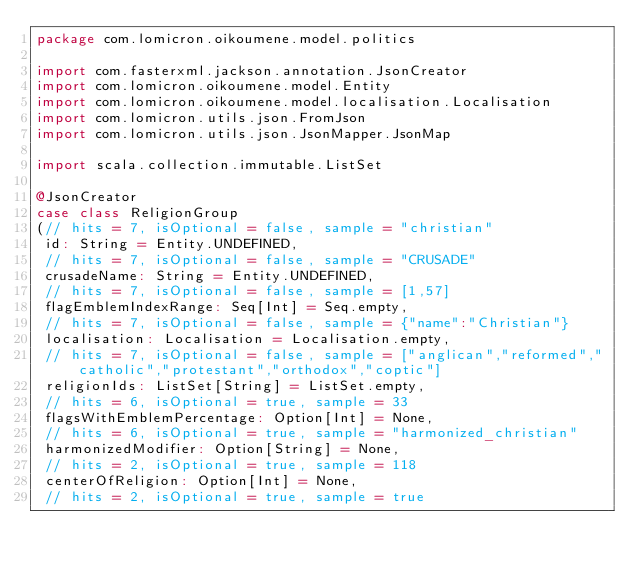Convert code to text. <code><loc_0><loc_0><loc_500><loc_500><_Scala_>package com.lomicron.oikoumene.model.politics

import com.fasterxml.jackson.annotation.JsonCreator
import com.lomicron.oikoumene.model.Entity
import com.lomicron.oikoumene.model.localisation.Localisation
import com.lomicron.utils.json.FromJson
import com.lomicron.utils.json.JsonMapper.JsonMap

import scala.collection.immutable.ListSet

@JsonCreator
case class ReligionGroup
(// hits = 7, isOptional = false, sample = "christian"
 id: String = Entity.UNDEFINED,
 // hits = 7, isOptional = false, sample = "CRUSADE"
 crusadeName: String = Entity.UNDEFINED,
 // hits = 7, isOptional = false, sample = [1,57]
 flagEmblemIndexRange: Seq[Int] = Seq.empty,
 // hits = 7, isOptional = false, sample = {"name":"Christian"}
 localisation: Localisation = Localisation.empty,
 // hits = 7, isOptional = false, sample = ["anglican","reformed","catholic","protestant","orthodox","coptic"]
 religionIds: ListSet[String] = ListSet.empty,
 // hits = 6, isOptional = true, sample = 33
 flagsWithEmblemPercentage: Option[Int] = None,
 // hits = 6, isOptional = true, sample = "harmonized_christian"
 harmonizedModifier: Option[String] = None,
 // hits = 2, isOptional = true, sample = 118
 centerOfReligion: Option[Int] = None,
 // hits = 2, isOptional = true, sample = true</code> 